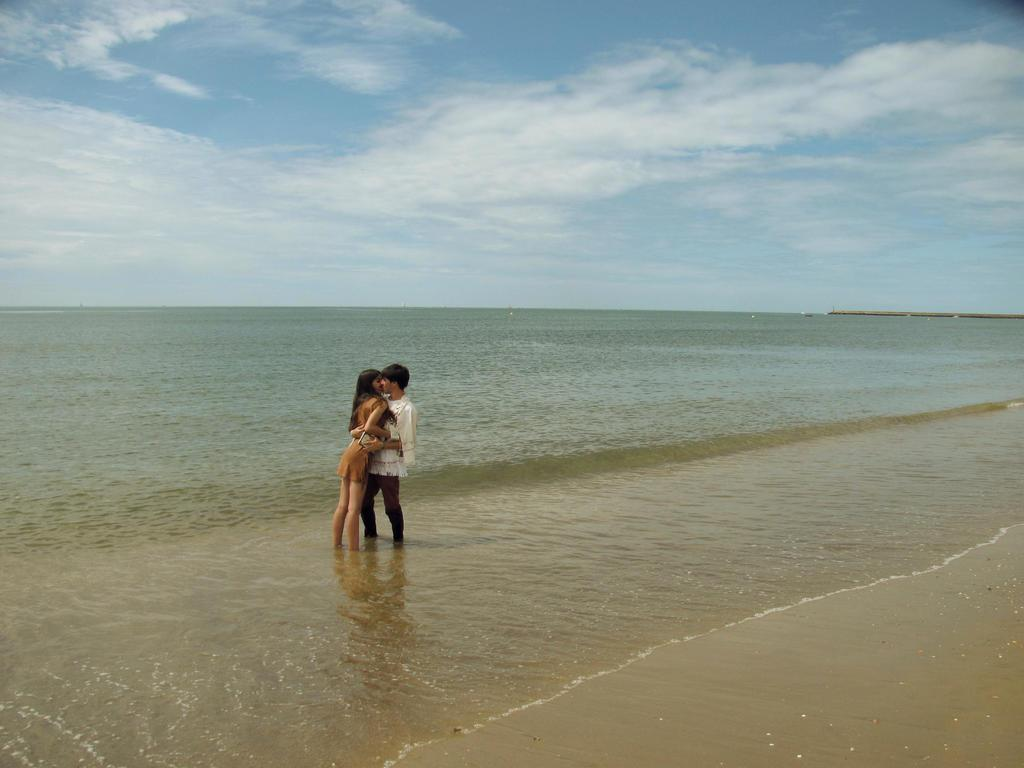What are the two people in the image doing? The man and woman are kissing each other. Can you describe the positions of the man and woman in the image? The man and woman are standing. What is the relationship between the man and woman in the image? The facts provided do not give information about the relationship between the man and woman. What type of cheese is visible on the woman's head in the image? There is no cheese present in the image. How many children are visible in the image? There are no children present in the image. 